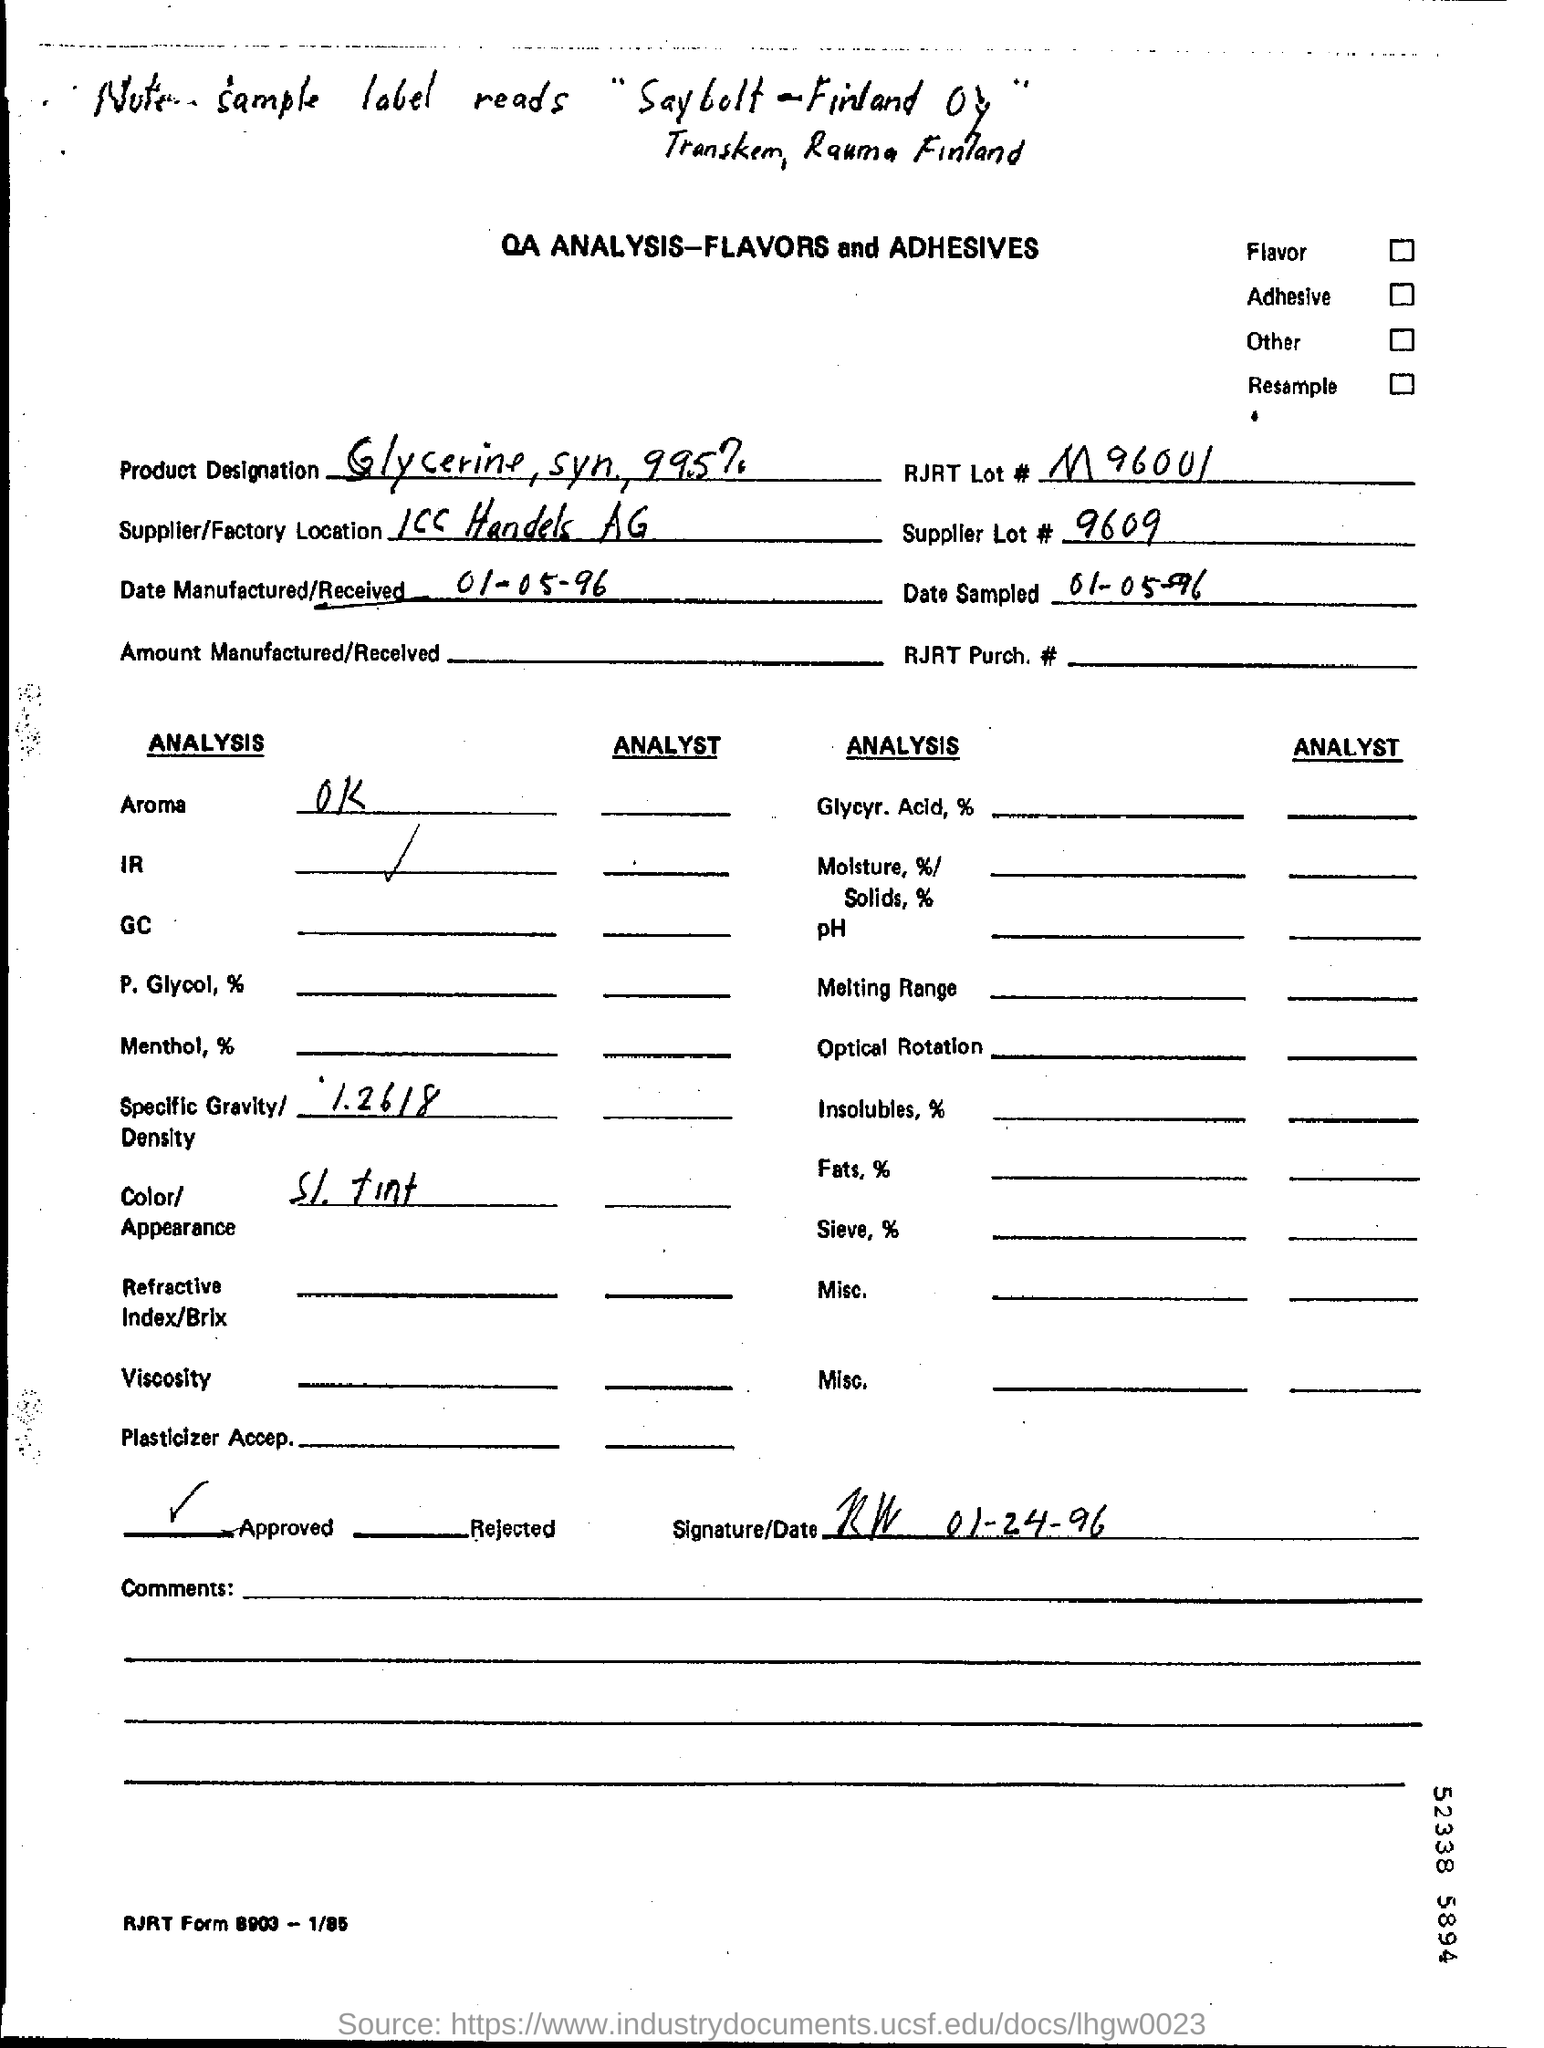What is Date Manufactured/ Received?
Ensure brevity in your answer.  01-05-96. Color/Appearance given in ANALYSIS?
Ensure brevity in your answer.  SI. tint. Specific Gravity/Density given in ANALYSIS?
Give a very brief answer. 1.2618. 